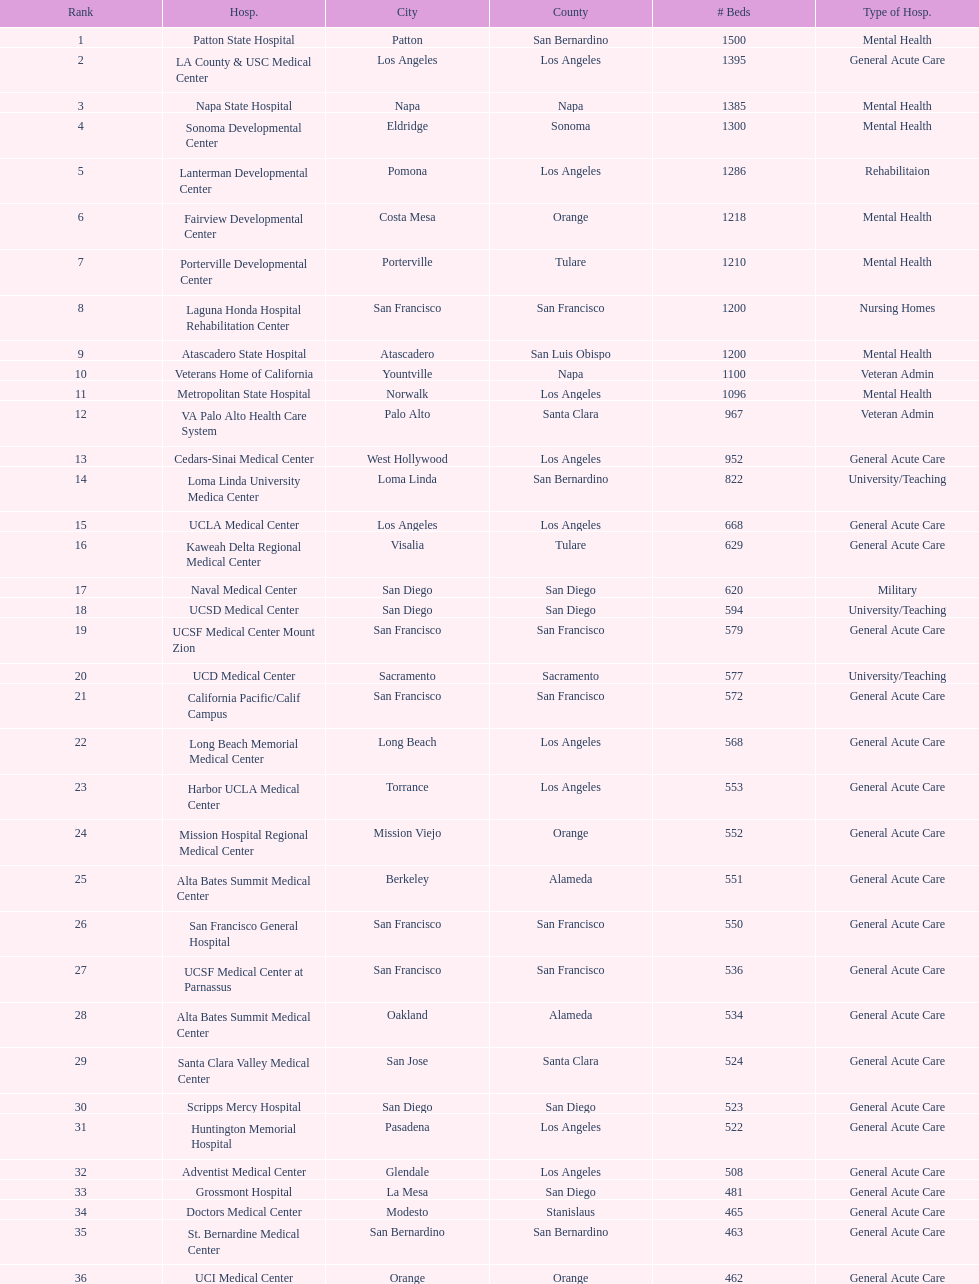Does patton state hospital in the city of patton in san bernardino county have more mental health hospital beds than atascadero state hospital in atascadero, san luis obispo county? Yes. 